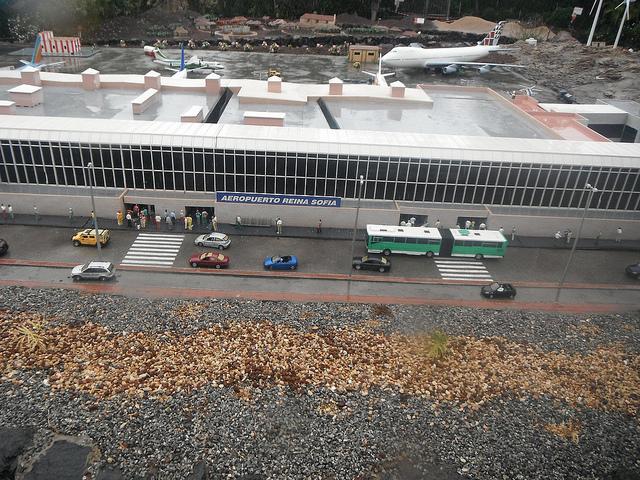How many different types of vehicles are there?
Answer briefly. 8. How many buses are there?
Quick response, please. 1. Where are the cars?
Keep it brief. Street. 